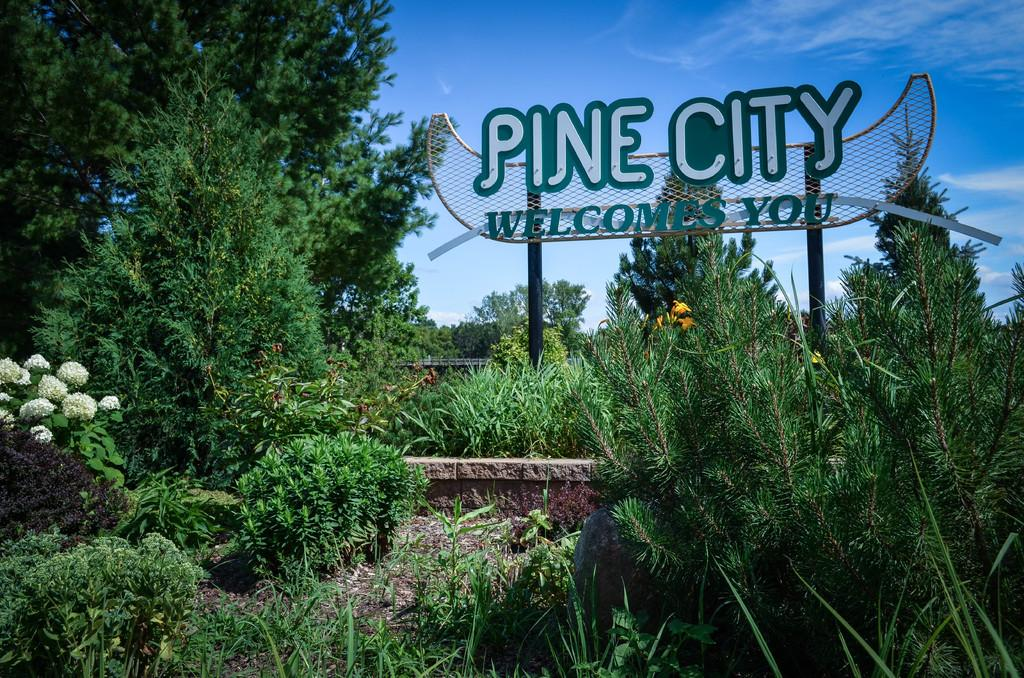What type of vegetation can be seen in the image? There are trees and plants in the image. What is located in the center of the image? There is a board in the center of the image. What can be seen in the background of the image? Sky is visible in the background of the image. How many loaves of bread are stacked on the board in the image? There is no loaf of bread present in the image; it features trees, plants, and a board. What type of mass is being performed by the trees in the image? There is no mass being performed by the trees in the image; they are simply standing in the image. 